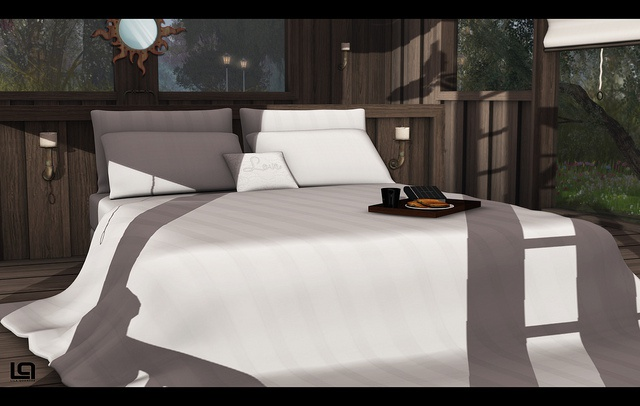Describe the objects in this image and their specific colors. I can see bed in black, lightgray, gray, and darkgray tones and cup in black, darkgray, and gray tones in this image. 